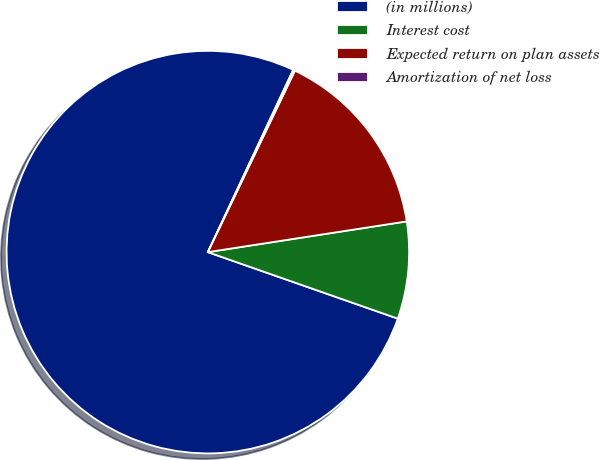Convert chart. <chart><loc_0><loc_0><loc_500><loc_500><pie_chart><fcel>(in millions)<fcel>Interest cost<fcel>Expected return on plan assets<fcel>Amortization of net loss<nl><fcel>76.61%<fcel>7.8%<fcel>15.44%<fcel>0.15%<nl></chart> 